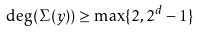Convert formula to latex. <formula><loc_0><loc_0><loc_500><loc_500>\deg ( \Sigma ( y ) ) \geq \max \{ 2 , 2 ^ { d } - 1 \}</formula> 